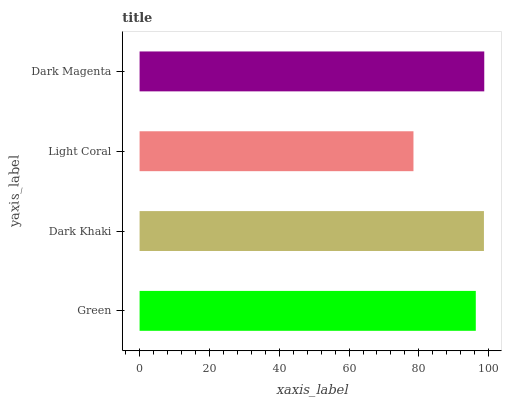Is Light Coral the minimum?
Answer yes or no. Yes. Is Dark Magenta the maximum?
Answer yes or no. Yes. Is Dark Khaki the minimum?
Answer yes or no. No. Is Dark Khaki the maximum?
Answer yes or no. No. Is Dark Khaki greater than Green?
Answer yes or no. Yes. Is Green less than Dark Khaki?
Answer yes or no. Yes. Is Green greater than Dark Khaki?
Answer yes or no. No. Is Dark Khaki less than Green?
Answer yes or no. No. Is Dark Khaki the high median?
Answer yes or no. Yes. Is Green the low median?
Answer yes or no. Yes. Is Green the high median?
Answer yes or no. No. Is Light Coral the low median?
Answer yes or no. No. 